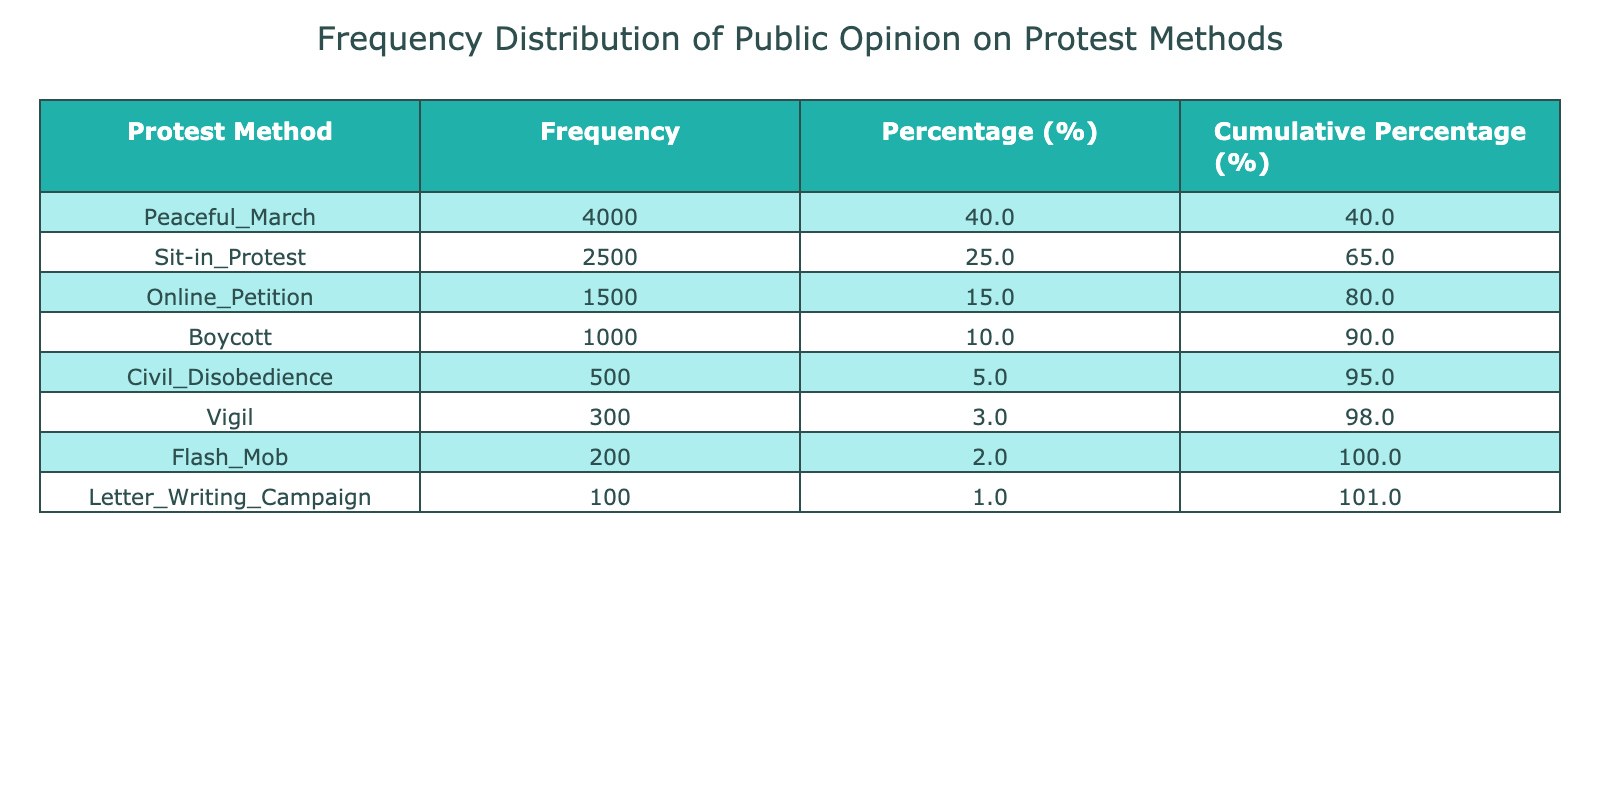What is the public opinion percentage for the Peaceful March protest method? The table shows that the public opinion percentage for the Peaceful March is listed directly under the 'Percentage (%)' column. The value for Peaceful March is 40%.
Answer: 40% Which protest method has the lowest public opinion percentage? By scanning the 'Percentage (%)' column, we can identify that the Letter Writing Campaign has the lowest value, which is 1%.
Answer: 1% What is the cumulative percentage for Sit-in Protest? The cumulative percentage for Sit-in Protest can be found in the 'Cumulative Percentage (%)' column. It adds the percentages of all methods up to Sit-in Protest, which is 65% (40% + 25%).
Answer: 65% Is the public opinion percentage for Civil Disobedience greater than that for Boycott? From the table, the percentage for Civil Disobedience is 5% and for Boycott is 10%. Since 5% is not greater than 10%, the statement is false.
Answer: No What is the total public opinion percentage for all protest methods listed? To find the total public opinion percentage, we can sum all the individual percentages from the table: 40 + 25 + 15 + 10 + 5 + 3 + 2 + 1 = 100%.
Answer: 100% If we combine the public opinion percentages for Online Petition, Boycott, and Civil Disobedience, what is the total? We can add these three values together: Online Petition (15%), Boycott (10%), and Civil Disobedience (5%) gives us a total of 30%.
Answer: 30% What is the difference in public opinion percentage between the most favored and the least favored protest methods? The most favored protest method is Peaceful March with a percentage of 40%, and the least favored is Letter Writing Campaign with 1%. The difference is calculated as 40% - 1% = 39%.
Answer: 39% Which protest method has a higher public opinion percentage: Flash Mob or Vigil? According to the table, Flash Mob has a public opinion percentage of 2% while Vigil has 3%. Since 3% is greater than 2%, Vigil has a higher percentage.
Answer: Vigil What is the average public opinion percentage of all protest methods? To calculate the average, we sum the percentages (100%) and divide by the number of protest methods (8): 100% / 8 = 12.5%.
Answer: 12.5% 